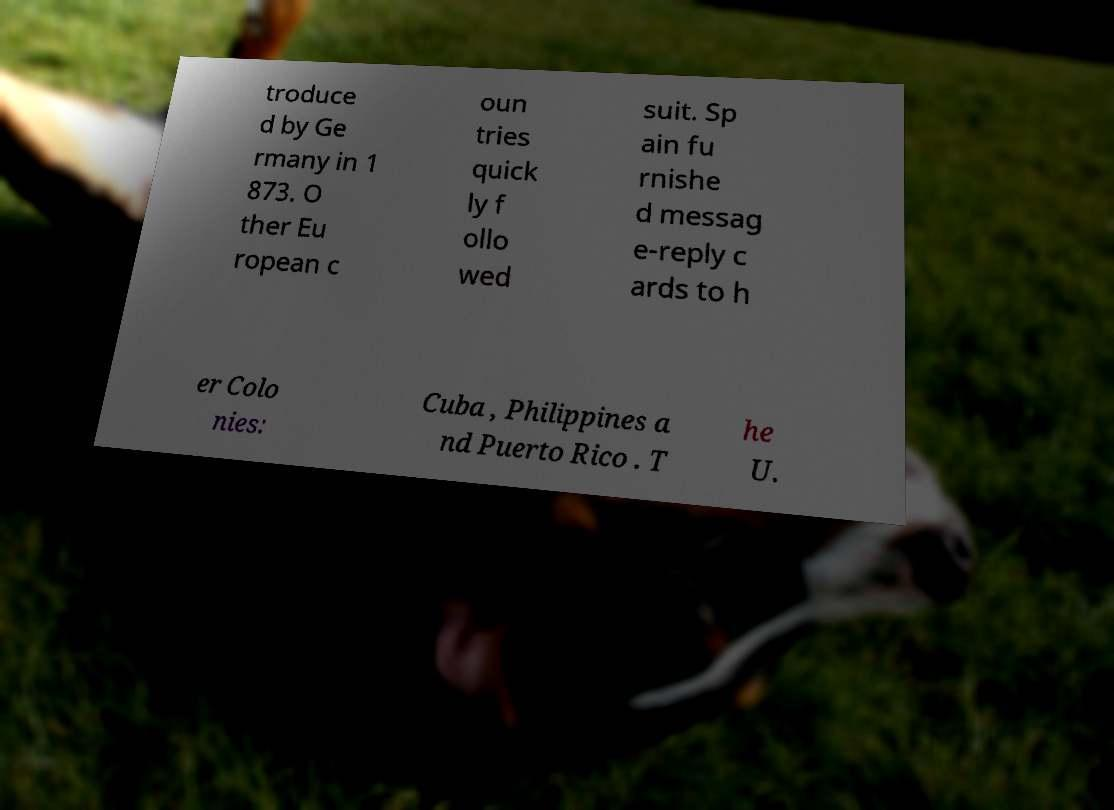What messages or text are displayed in this image? I need them in a readable, typed format. troduce d by Ge rmany in 1 873. O ther Eu ropean c oun tries quick ly f ollo wed suit. Sp ain fu rnishe d messag e-reply c ards to h er Colo nies: Cuba , Philippines a nd Puerto Rico . T he U. 